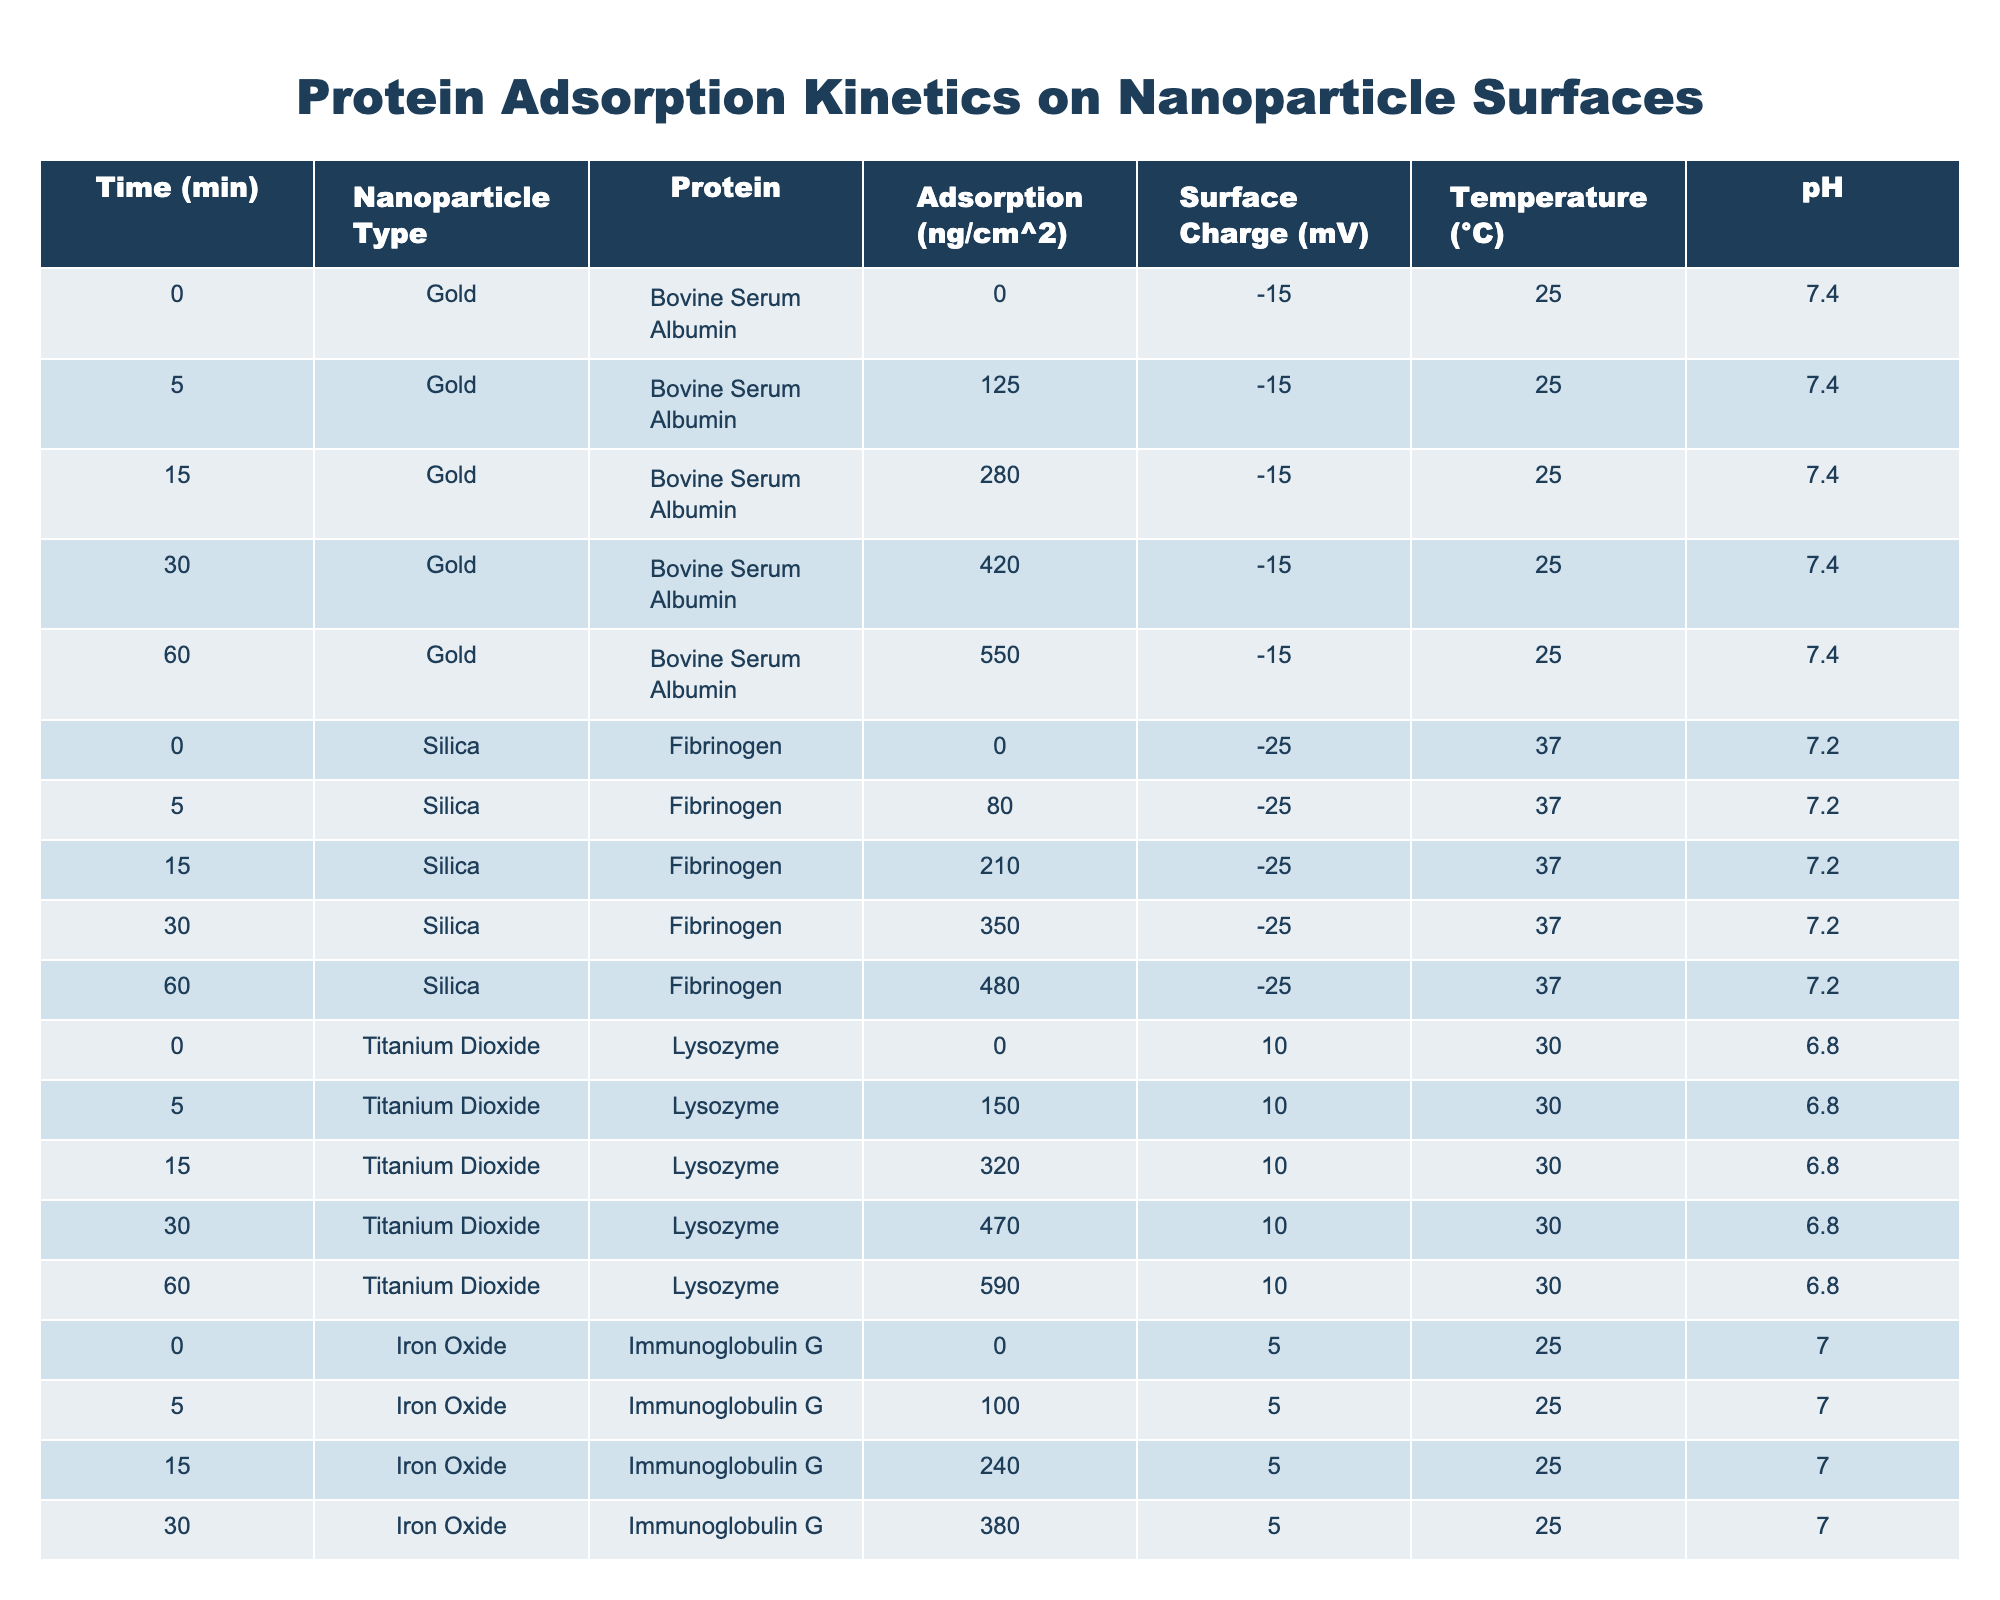What is the protein adsorption at 5 minutes for Gold nanoparticles? At the 5-minute mark in the table for Gold nanoparticles and Bovine Serum Albumin, the adsorption value is listed as 125 ng/cm².
Answer: 125 ng/cm² What is the maximum adsorption recorded for the protein Fibrinogen over 60 minutes on Silica nanoparticles? The table indicates the maximum adsorption for Fibrinogen on Silica nanoparticles occurs at 60 minutes with a value of 480 ng/cm².
Answer: 480 ng/cm² Which nanoparticle type shows the highest protein adsorption at 60 minutes? By comparing the final adsorption values across all nanoparticle types at the 60-minute mark, Titanium Dioxide holds the highest value at 590 ng/cm² for Lysozyme protein.
Answer: Titanium Dioxide What is the adsorption difference for Fibrinogen on Silica nanoparticles between 0 minutes and 60 minutes? The adsorption at 0 minutes is 0 ng/cm² and at 60 minutes is 480 ng/cm². The difference calculated is 480 - 0 = 480 ng/cm².
Answer: 480 ng/cm² Is the surface charge for Gold nanoparticles positive, negative, or neutral? The surface charge for Gold nanoparticles, as shown in the table, is -15 mV, which indicates it is negative.
Answer: Negative What is the average protein adsorption for Lysozyme on Titanium Dioxide over the 60 minutes? The adsorption values for Lysozyme at different time points are (0 + 150 + 320 + 470 + 590) ng/cm². The sum is 1530 ng/cm², divided by 5 gives an average of 306 ng/cm².
Answer: 306 ng/cm² How does the adsorption of Bovine Serum Albumin on Gold nanoparticles compare to that of Cytochrome C on Graphene Oxide after 60 minutes? After 60 minutes, the adsorption for Bovine Serum Albumin on Gold is 550 ng/cm² while for Cytochrome C on Graphene Oxide it is 460 ng/cm². Thus, Bovine Serum Albumin adsorbs more by (550 - 460) = 90 ng/cm².
Answer: Bovine Serum Albumin adsorbs more by 90 ng/cm² What are the adsorption values of Immunoglobulin G at 15 minutes and 60 minutes on Iron Oxide? The table provides an adsorption of 240 ng/cm² at 15 minutes and 510 ng/cm² at 60 minutes for Immunoglobulin G on Iron Oxide.
Answer: 240 ng/cm² at 15 min and 510 ng/cm² at 60 min What is the increase in protein adsorption from 0 to 30 minutes for Cytochrome C on Graphene Oxide? The values are 0 ng/cm² at 0 minutes and 330 ng/cm² at 30 minutes. The increase is calculated as 330 - 0 = 330 ng/cm².
Answer: 330 ng/cm² Does the temperature affect protein adsorption across all nanoparticle types? The temperature varies among the nanoparticle types with Gold and Iron Oxide tested at 25°C, Silica at 37°C, Titanium Dioxide at 30°C, and Graphene Oxide at 37°C, indicating there is variability in temperature but no direct conclusion on the effect can be drawn just from the adsorption data.
Answer: No direct conclusion can be drawn 